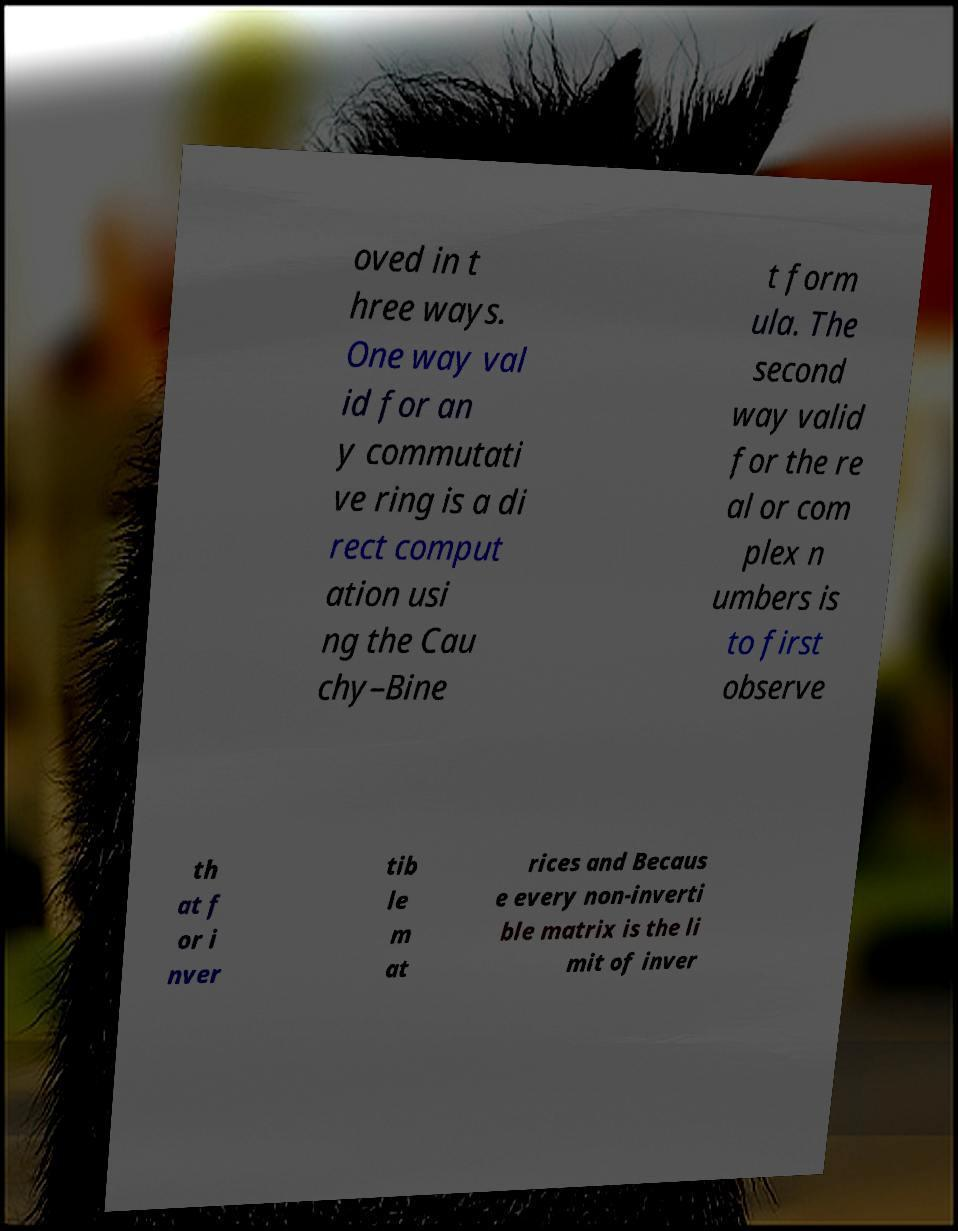Could you assist in decoding the text presented in this image and type it out clearly? oved in t hree ways. One way val id for an y commutati ve ring is a di rect comput ation usi ng the Cau chy–Bine t form ula. The second way valid for the re al or com plex n umbers is to first observe th at f or i nver tib le m at rices and Becaus e every non-inverti ble matrix is the li mit of inver 